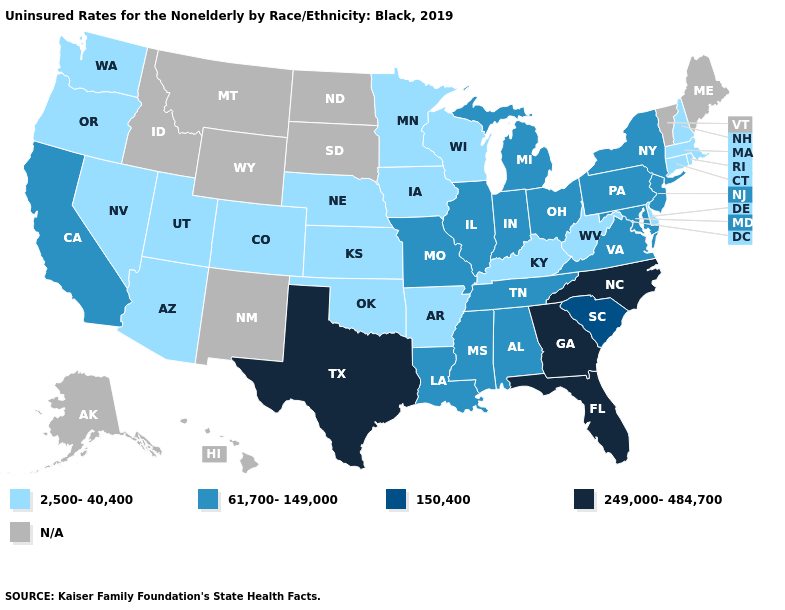Does Florida have the highest value in the USA?
Keep it brief. Yes. What is the value of Pennsylvania?
Keep it brief. 61,700-149,000. Which states have the lowest value in the Northeast?
Answer briefly. Connecticut, Massachusetts, New Hampshire, Rhode Island. Name the states that have a value in the range 249,000-484,700?
Write a very short answer. Florida, Georgia, North Carolina, Texas. Name the states that have a value in the range N/A?
Be succinct. Alaska, Hawaii, Idaho, Maine, Montana, New Mexico, North Dakota, South Dakota, Vermont, Wyoming. Name the states that have a value in the range 150,400?
Short answer required. South Carolina. Is the legend a continuous bar?
Give a very brief answer. No. What is the value of Massachusetts?
Answer briefly. 2,500-40,400. What is the lowest value in states that border Illinois?
Quick response, please. 2,500-40,400. Is the legend a continuous bar?
Be succinct. No. What is the highest value in states that border Maryland?
Short answer required. 61,700-149,000. Name the states that have a value in the range 249,000-484,700?
Quick response, please. Florida, Georgia, North Carolina, Texas. What is the value of Connecticut?
Keep it brief. 2,500-40,400. What is the value of Iowa?
Short answer required. 2,500-40,400. Name the states that have a value in the range N/A?
Be succinct. Alaska, Hawaii, Idaho, Maine, Montana, New Mexico, North Dakota, South Dakota, Vermont, Wyoming. 